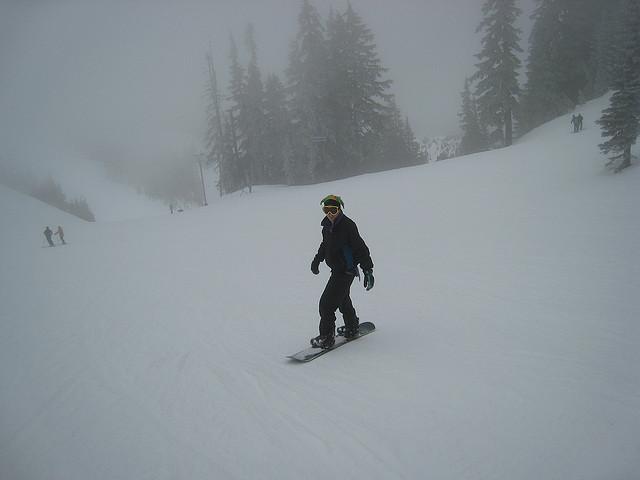What is man doing?
Quick response, please. Snowboarding. Was this photo taken in India?
Give a very brief answer. No. What is attached to the person's feet?
Write a very short answer. Snowboard. What is the most colorful item in this picture?
Keep it brief. Hat. Is there tracks thru the snow?
Short answer required. Yes. How far must one travel to reach the top of this mountain?
Be succinct. Far. What is this person wearing on their face?
Answer briefly. Goggles. 